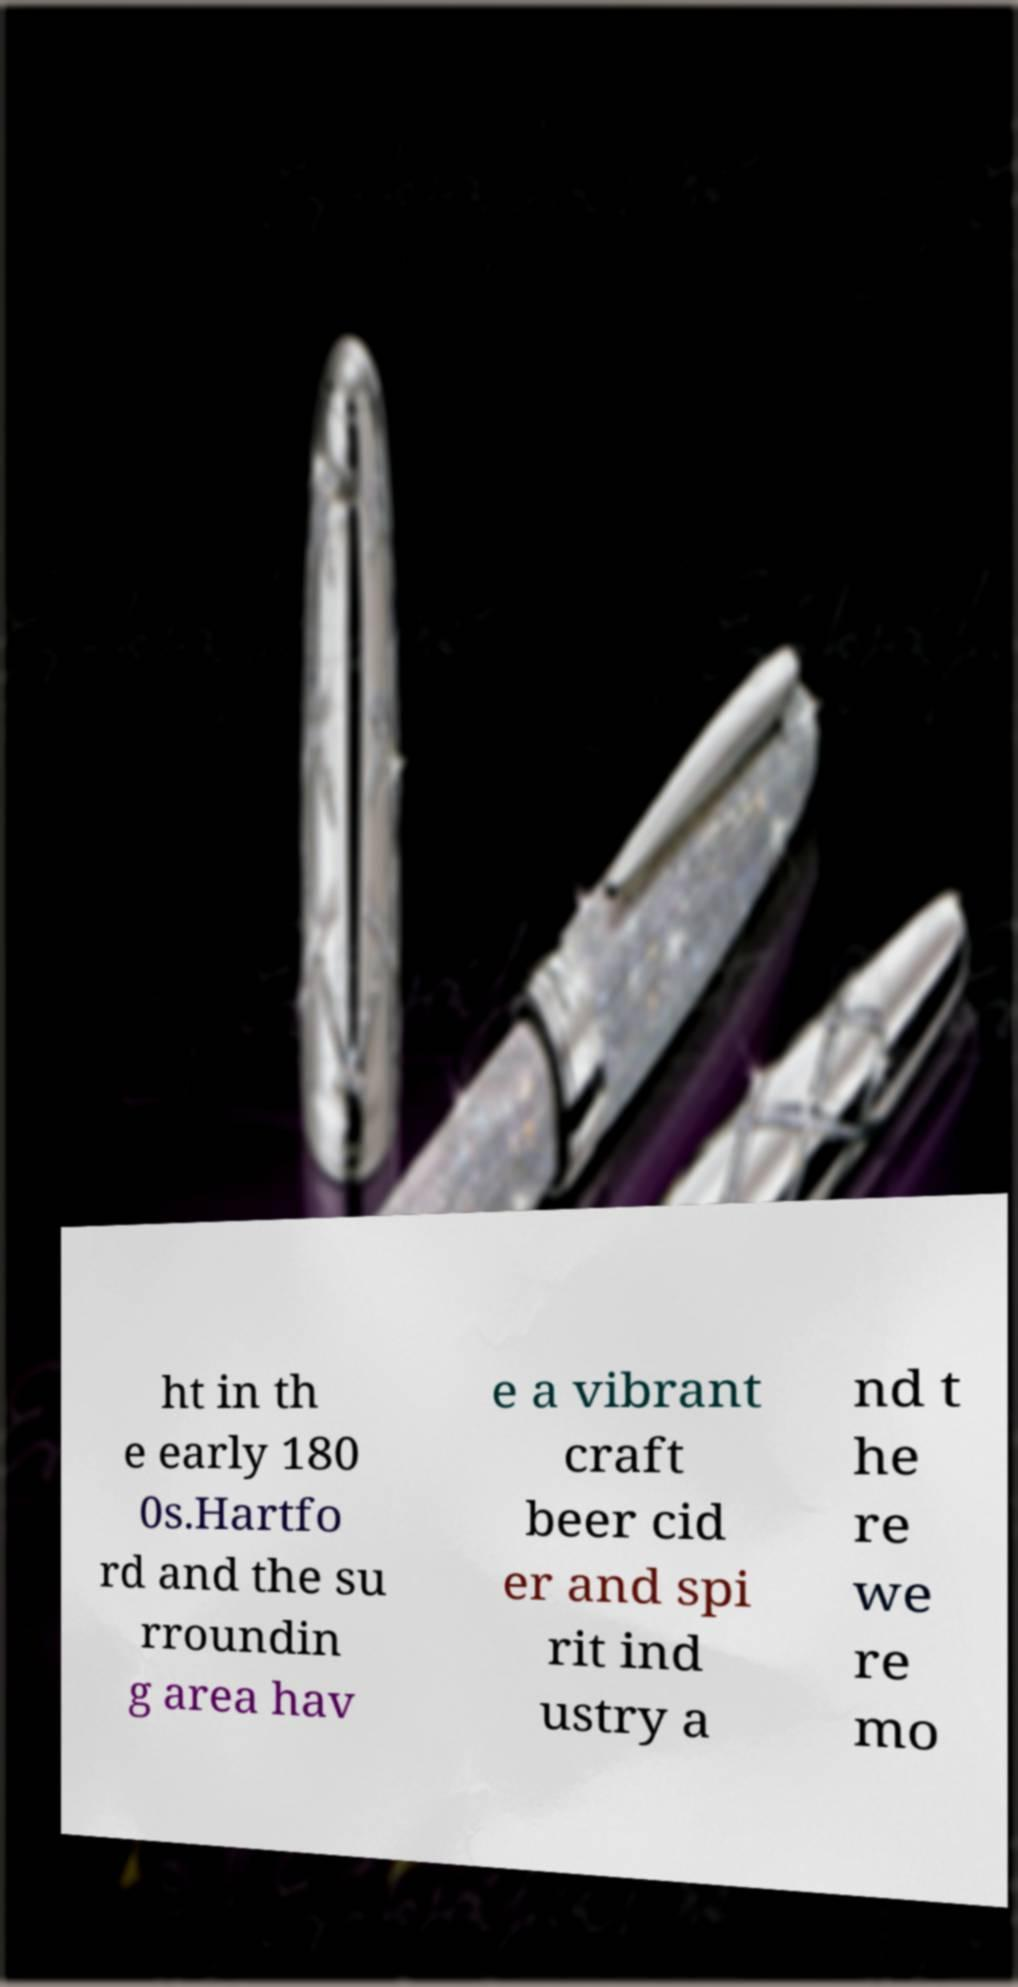Can you accurately transcribe the text from the provided image for me? ht in th e early 180 0s.Hartfo rd and the su rroundin g area hav e a vibrant craft beer cid er and spi rit ind ustry a nd t he re we re mo 